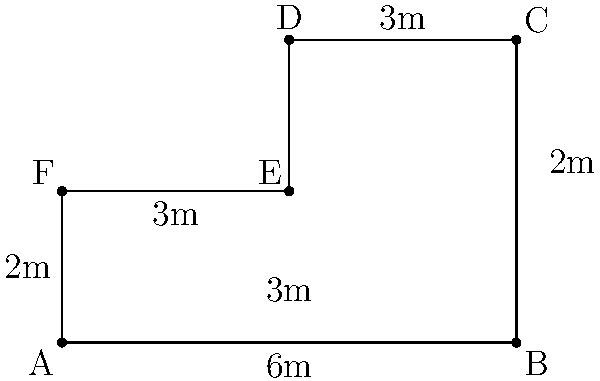As you plan your garden layout for your new home, you've designed an irregularly shaped plot. The dimensions of each side are shown in the diagram. Calculate the perimeter of this garden plot. To calculate the perimeter of the irregular garden plot, we need to sum up the lengths of all sides:

1. Side AB: $6$ meters
2. Side BC: $4$ meters
3. Side CD: $3$ meters
4. Side DE: $2$ meters
5. Side EF: $3$ meters
6. Side FA: $2$ meters

Now, let's add all these lengths:

$$\text{Perimeter} = 6 + 4 + 3 + 2 + 3 + 2 = 20$$

Therefore, the perimeter of the garden plot is 20 meters.
Answer: $20$ meters 